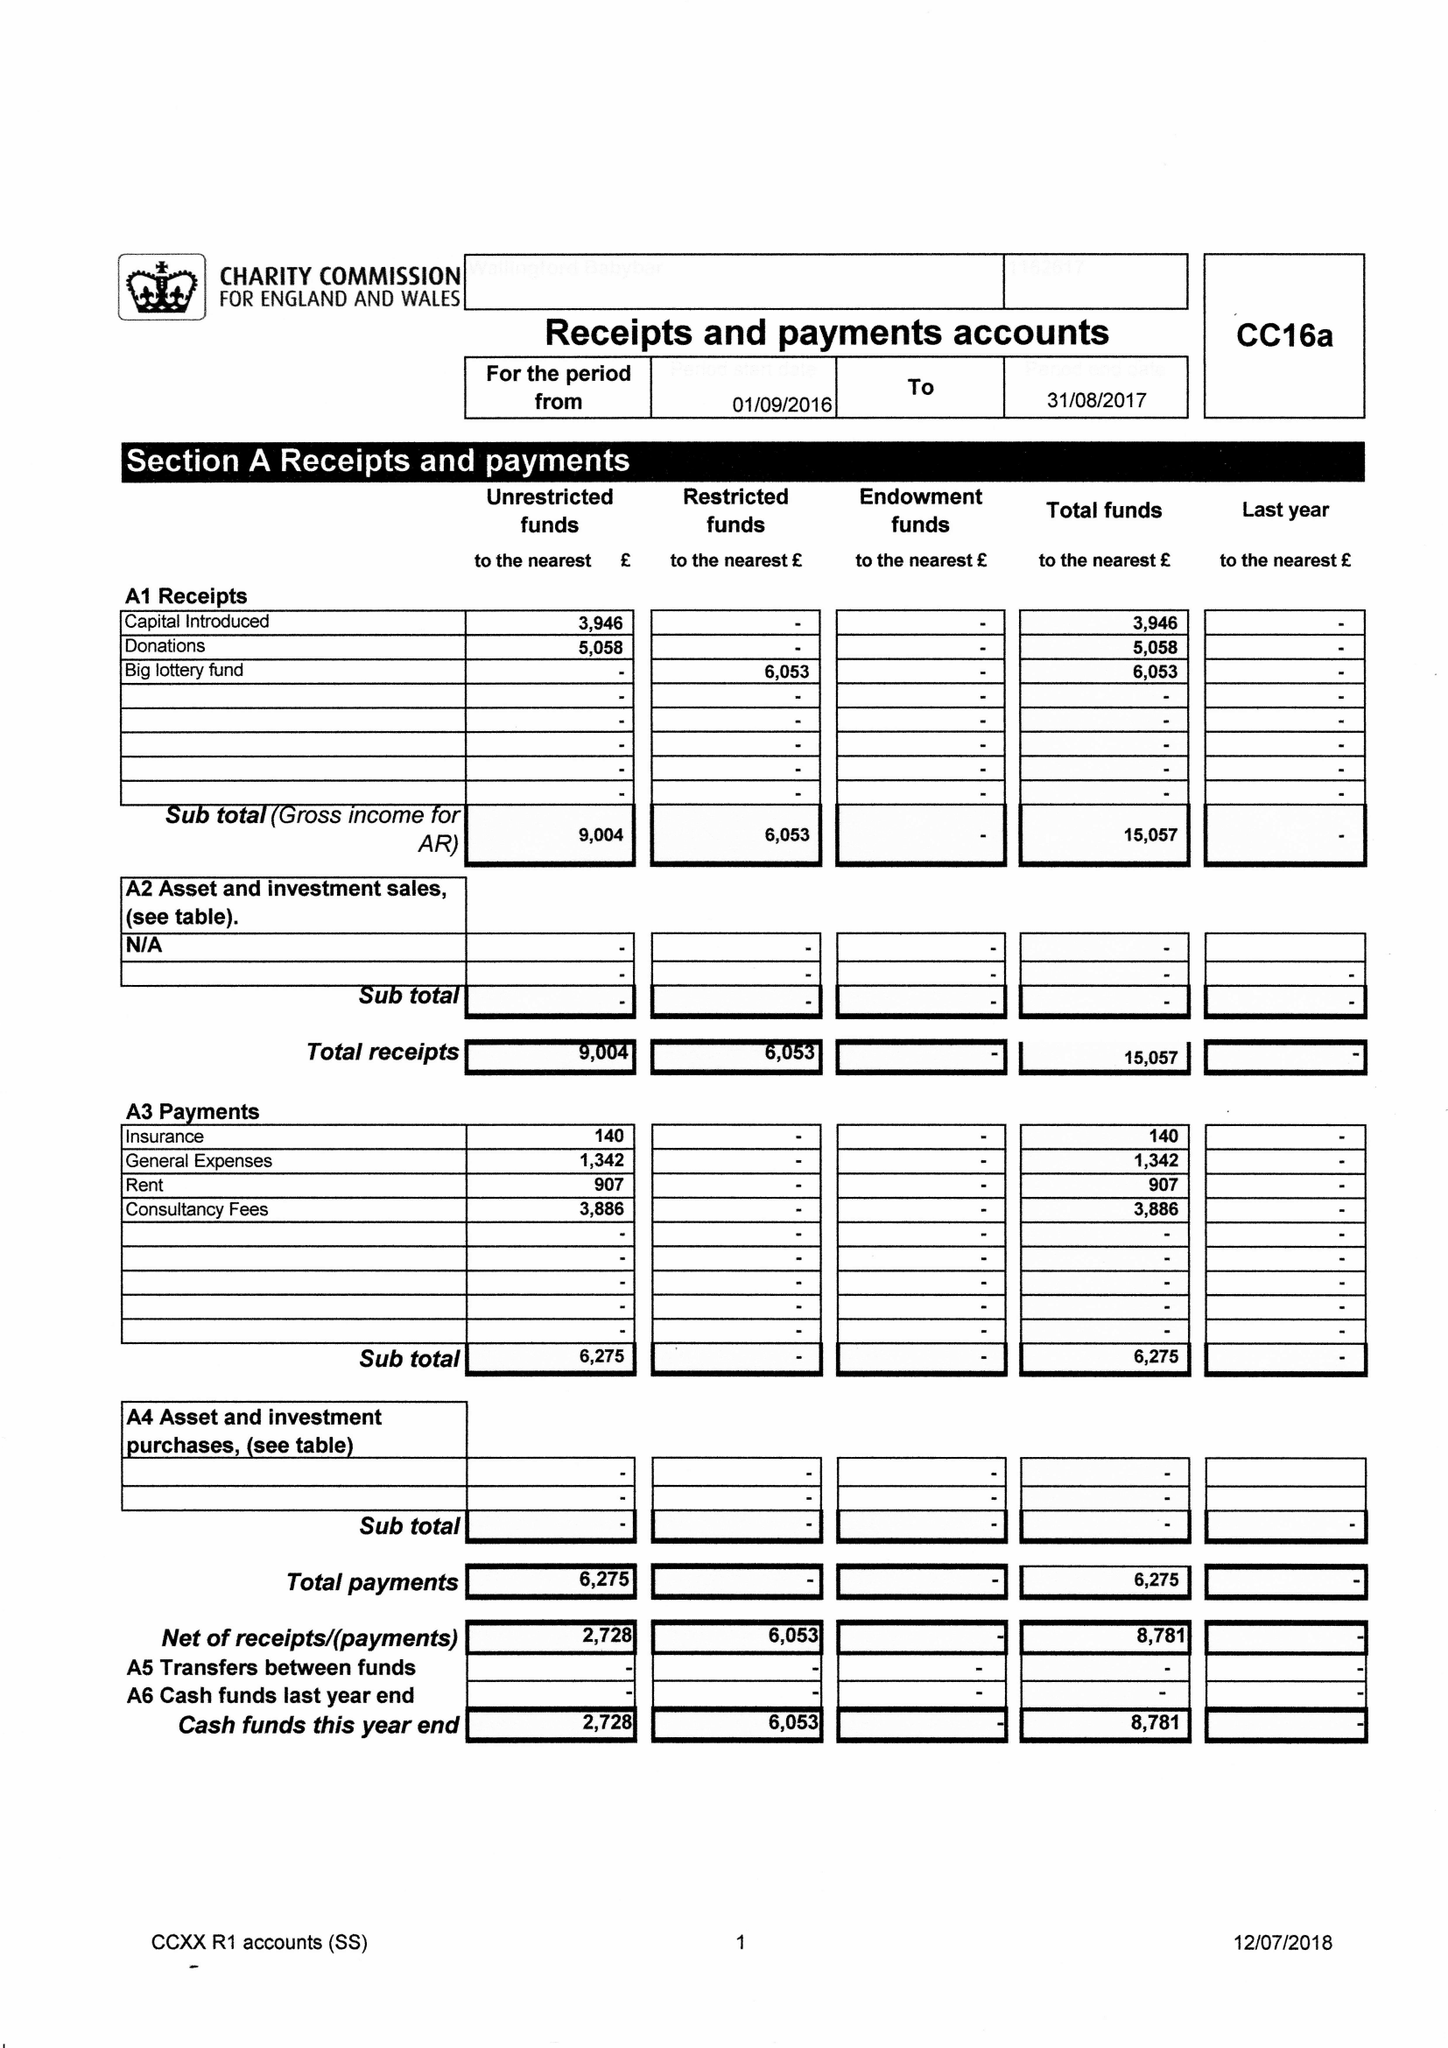What is the value for the spending_annually_in_british_pounds?
Answer the question using a single word or phrase. 6530.00 